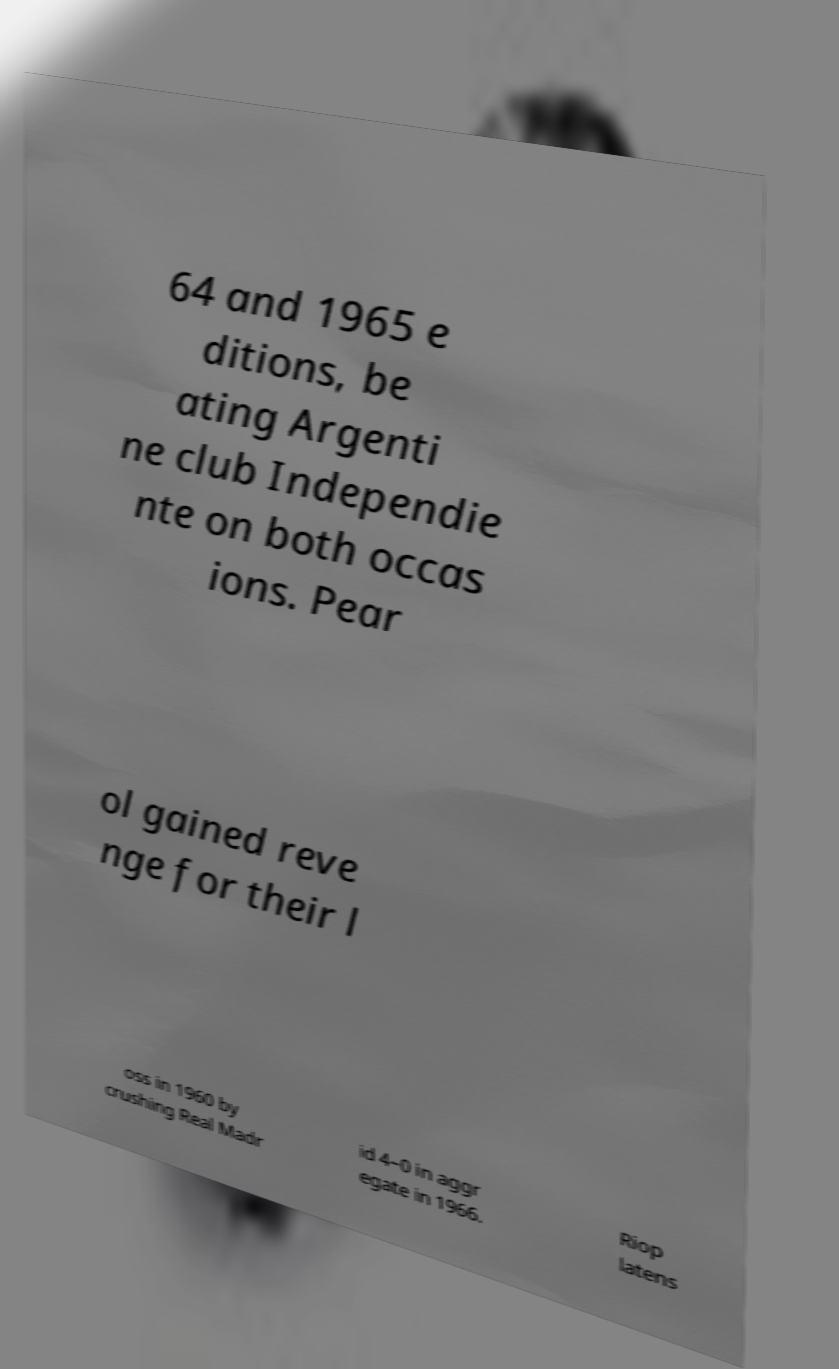Can you accurately transcribe the text from the provided image for me? 64 and 1965 e ditions, be ating Argenti ne club Independie nte on both occas ions. Pear ol gained reve nge for their l oss in 1960 by crushing Real Madr id 4–0 in aggr egate in 1966. Riop latens 